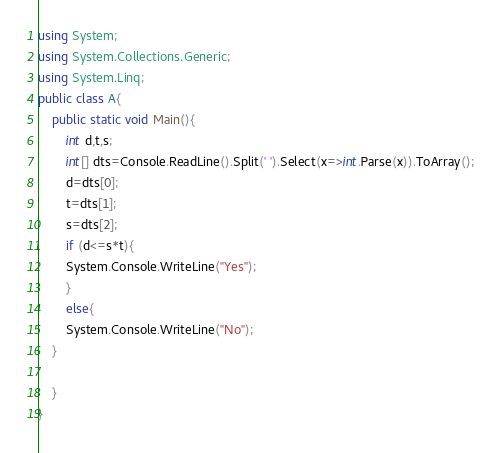<code> <loc_0><loc_0><loc_500><loc_500><_C#_>using System;
using System.Collections.Generic;
using System.Linq;
public class A{
    public static void Main(){
        int d,t,s;
        int[] dts=Console.ReadLine().Split(' ').Select(x=>int.Parse(x)).ToArray();
        d=dts[0];
        t=dts[1];
        s=dts[2];
        if (d<=s*t){
        System.Console.WriteLine("Yes");
        }
        else{
        System.Console.WriteLine("No");
    }
        
    }
}
</code> 